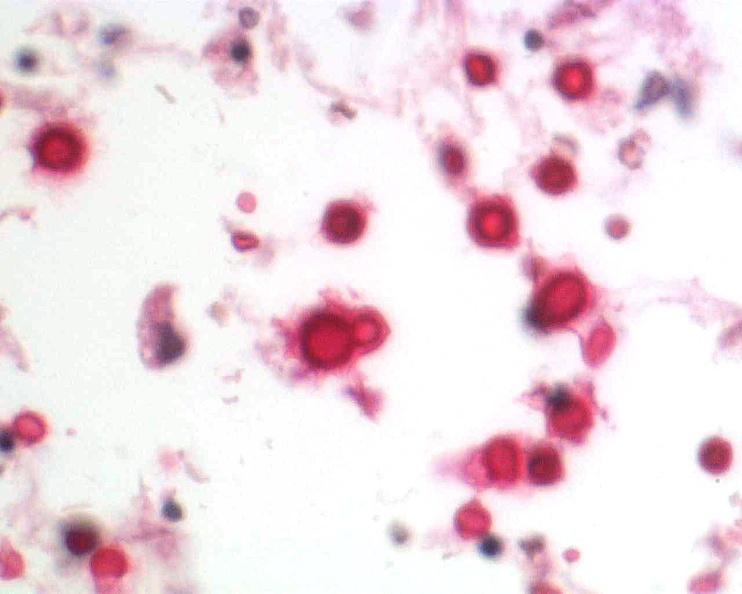what is present?
Answer the question using a single word or phrase. Nervous 